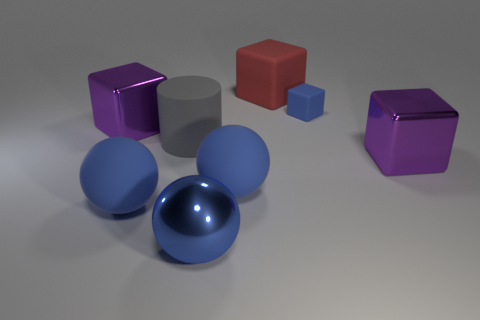Subtract 1 cubes. How many cubes are left? 3 Add 2 small matte balls. How many objects exist? 10 Subtract all cylinders. How many objects are left? 7 Add 6 tiny blue matte balls. How many tiny blue matte balls exist? 6 Subtract 0 gray spheres. How many objects are left? 8 Subtract all small blue blocks. Subtract all large brown matte objects. How many objects are left? 7 Add 5 red rubber cubes. How many red rubber cubes are left? 6 